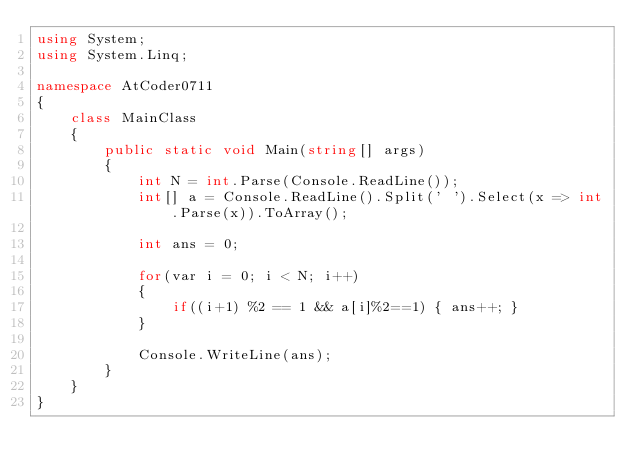<code> <loc_0><loc_0><loc_500><loc_500><_C#_>using System;
using System.Linq;

namespace AtCoder0711
{
    class MainClass
    {
        public static void Main(string[] args)
        {
            int N = int.Parse(Console.ReadLine());
            int[] a = Console.ReadLine().Split(' ').Select(x => int.Parse(x)).ToArray();

            int ans = 0;

            for(var i = 0; i < N; i++)
            {
                if((i+1) %2 == 1 && a[i]%2==1) { ans++; }
            }

            Console.WriteLine(ans);
        }
    }
}
</code> 